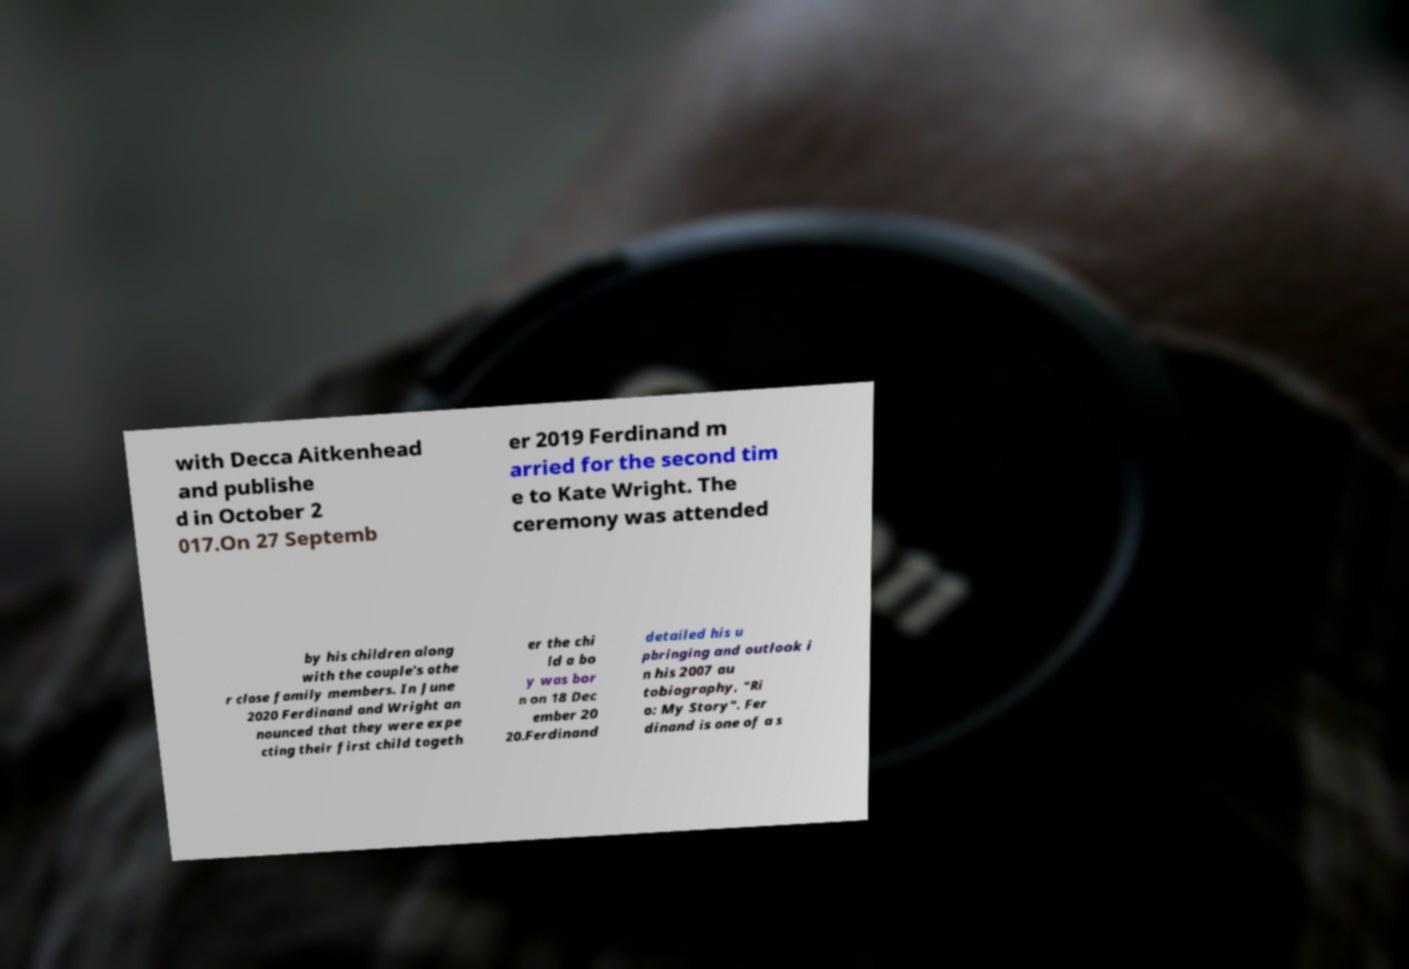Please identify and transcribe the text found in this image. with Decca Aitkenhead and publishe d in October 2 017.On 27 Septemb er 2019 Ferdinand m arried for the second tim e to Kate Wright. The ceremony was attended by his children along with the couple's othe r close family members. In June 2020 Ferdinand and Wright an nounced that they were expe cting their first child togeth er the chi ld a bo y was bor n on 18 Dec ember 20 20.Ferdinand detailed his u pbringing and outlook i n his 2007 au tobiography, "Ri o: My Story". Fer dinand is one of a s 